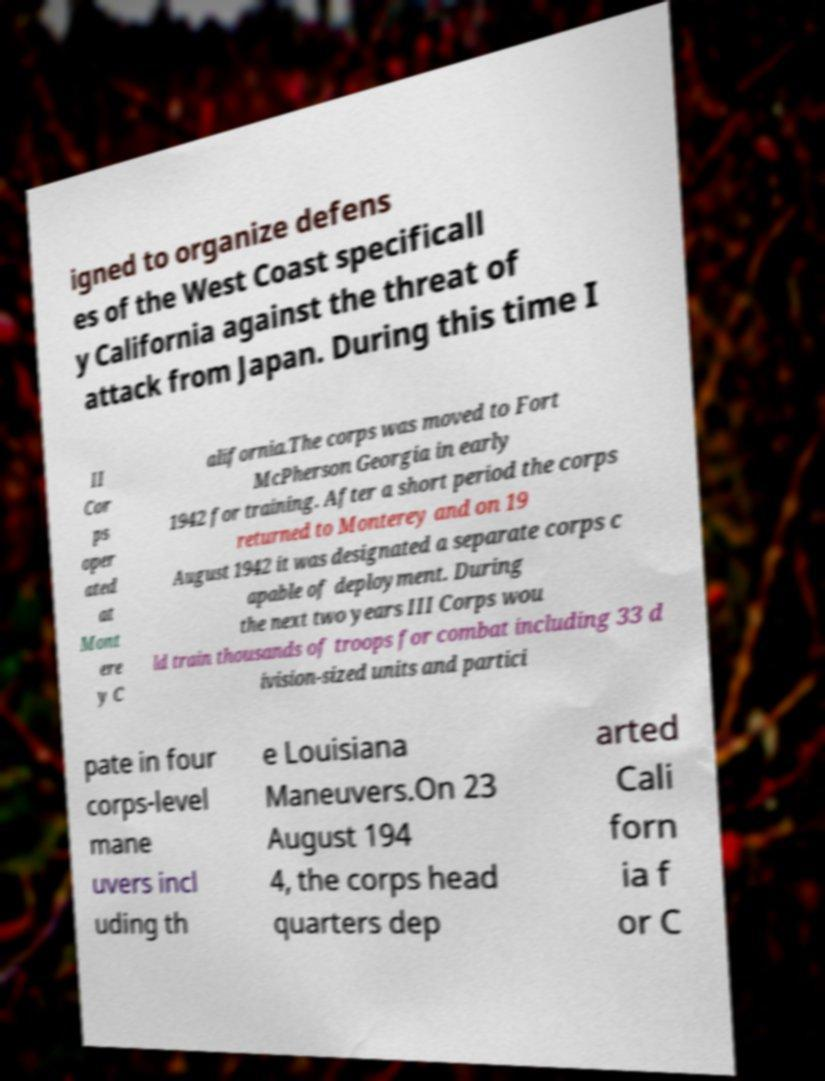For documentation purposes, I need the text within this image transcribed. Could you provide that? igned to organize defens es of the West Coast specificall y California against the threat of attack from Japan. During this time I II Cor ps oper ated at Mont ere y C alifornia.The corps was moved to Fort McPherson Georgia in early 1942 for training. After a short period the corps returned to Monterey and on 19 August 1942 it was designated a separate corps c apable of deployment. During the next two years III Corps wou ld train thousands of troops for combat including 33 d ivision-sized units and partici pate in four corps-level mane uvers incl uding th e Louisiana Maneuvers.On 23 August 194 4, the corps head quarters dep arted Cali forn ia f or C 